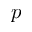<formula> <loc_0><loc_0><loc_500><loc_500>p</formula> 